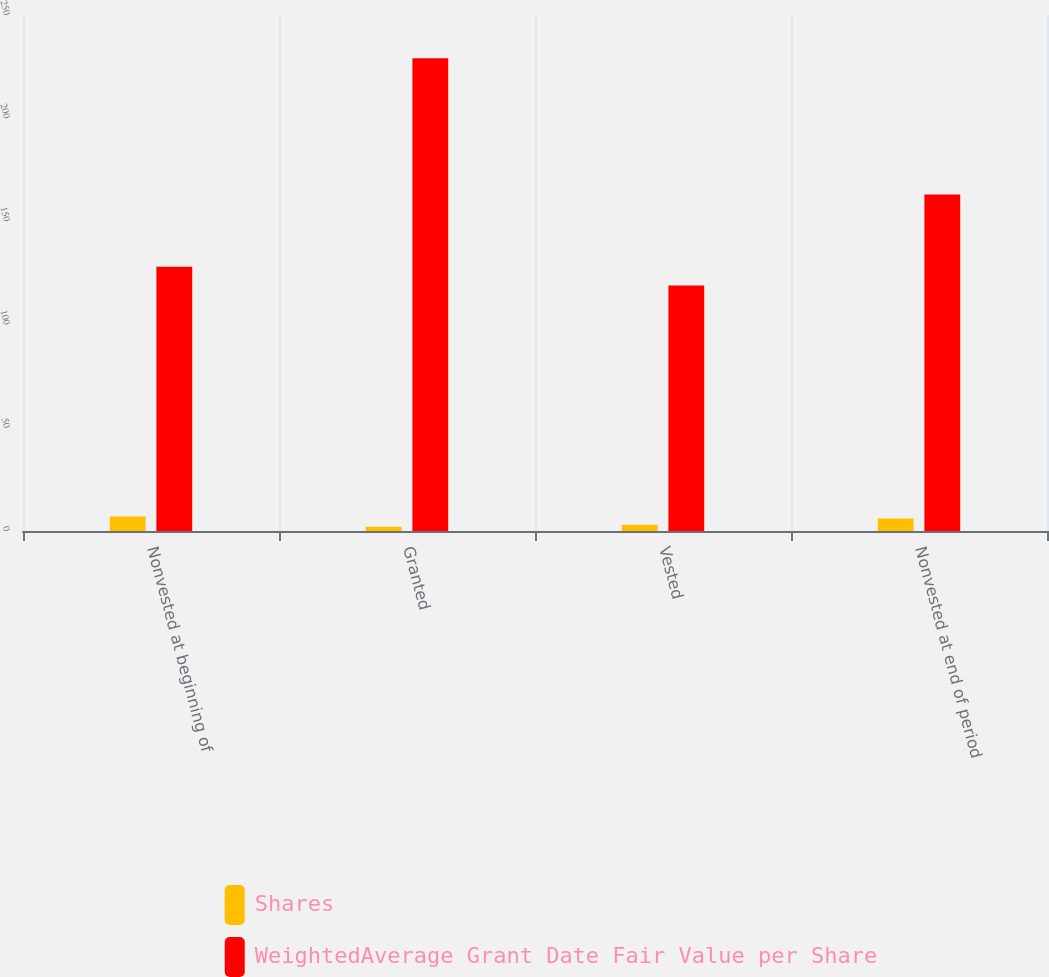Convert chart to OTSL. <chart><loc_0><loc_0><loc_500><loc_500><stacked_bar_chart><ecel><fcel>Nonvested at beginning of<fcel>Granted<fcel>Vested<fcel>Nonvested at end of period<nl><fcel>Shares<fcel>7<fcel>2<fcel>3<fcel>6<nl><fcel>WeightedAverage Grant Date Fair Value per Share<fcel>128<fcel>229<fcel>119<fcel>163<nl></chart> 